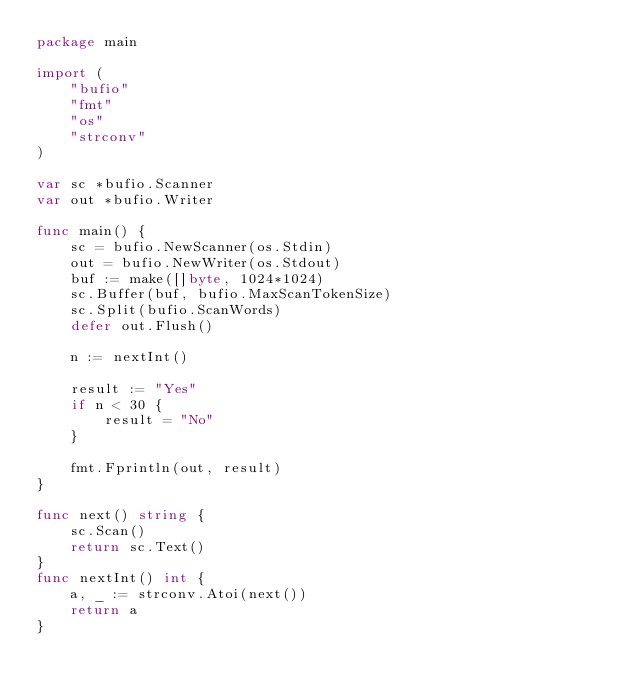Convert code to text. <code><loc_0><loc_0><loc_500><loc_500><_Go_>package main

import (
	"bufio"
	"fmt"
	"os"
	"strconv"
)

var sc *bufio.Scanner
var out *bufio.Writer

func main() {
	sc = bufio.NewScanner(os.Stdin)
	out = bufio.NewWriter(os.Stdout)
	buf := make([]byte, 1024*1024)
	sc.Buffer(buf, bufio.MaxScanTokenSize)
	sc.Split(bufio.ScanWords)
	defer out.Flush()

	n := nextInt()

	result := "Yes"
	if n < 30 {
		result = "No"
	}

	fmt.Fprintln(out, result)
}

func next() string {
	sc.Scan()
	return sc.Text()
}
func nextInt() int {
	a, _ := strconv.Atoi(next())
	return a
}
</code> 